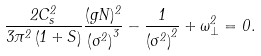Convert formula to latex. <formula><loc_0><loc_0><loc_500><loc_500>\frac { 2 C _ { s } ^ { 2 } } { 3 \pi ^ { 2 } \left ( 1 + S \right ) } \frac { ( g N ) ^ { 2 } } { \left ( \sigma ^ { 2 } \right ) ^ { 3 } } - \frac { 1 } { \left ( \sigma ^ { 2 } \right ) ^ { 2 } } + \omega _ { \perp } ^ { 2 } = 0 .</formula> 